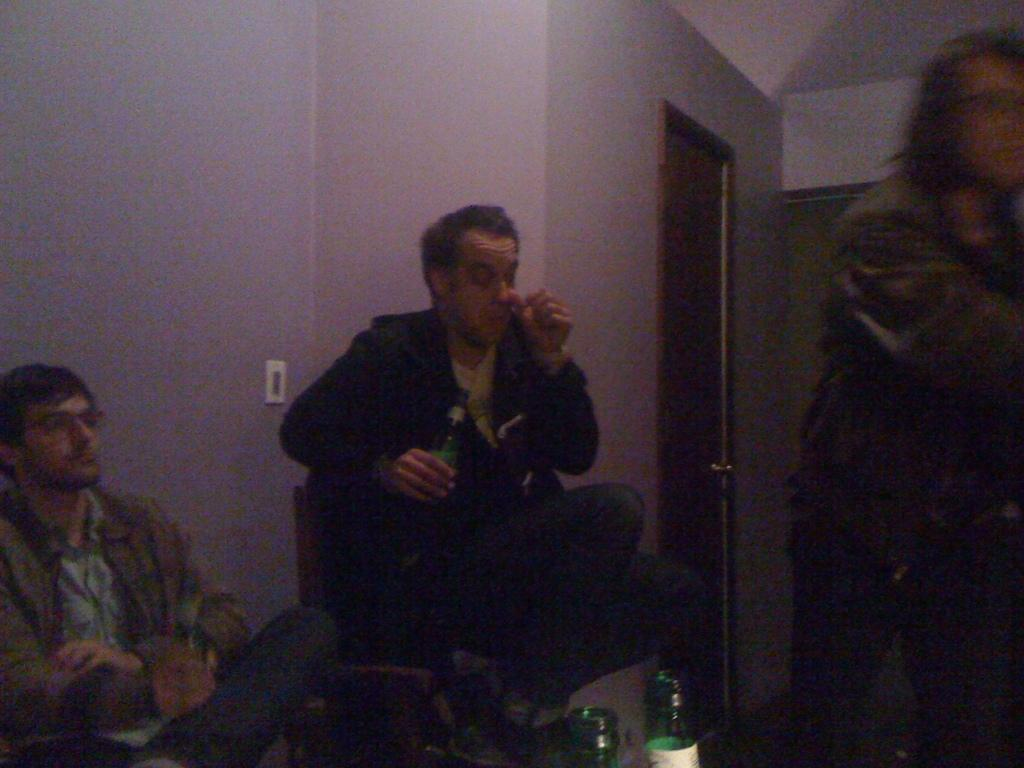How many people are sitting in the image? There are two men sitting in the image. What are the men holding in their hands? The men are holding bottles in their hands. Is there anyone standing in the image? Yes, there is a person standing in the image. What can be seen in the background of the image? There is a plain wall and a door visible in the background of the image. What type of nut is being requested by the person standing in the image? There is no mention of a nut or any request being made in the image. 